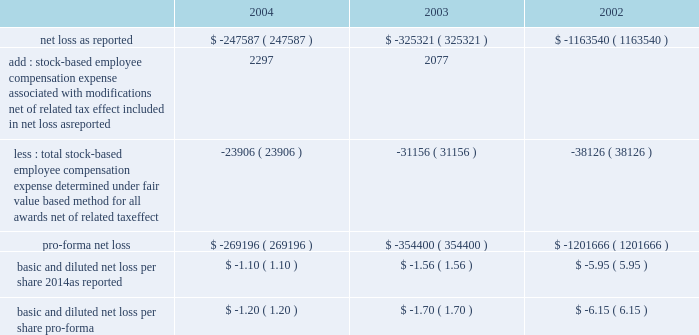American tower corporation and subsidiaries notes to consolidated financial statements 2014 ( continued ) stock-based compensation 2014the company complies with the provisions of sfas no .
148 , 201caccounting for stock-based compensation 2014transition and disclosure 2014an amendment of sfas no .
123 , 201d which provides optional transition guidance for those companies electing to voluntarily adopt the accounting provisions of sfas no .
123 .
The company continues to use accounting principles board opinion no .
25 ( apb no .
25 ) , 201caccounting for stock issued to employees , 201d to account for equity grants and awards to employees , officers and directors and has adopted the disclosure-only provisions of sfas no .
148 .
In accordance with apb no .
25 , the company recognizes compensation expense based on the excess , if any , of the quoted stock price at the grant date of the award or other measurement date over the amount an employee must pay to acquire the stock .
The company 2019s stock option plans are more fully described in note 13 .
In december 2004 , the fasb issued sfas no .
123r , 201cshare-based payment 201d ( sfas no .
123r ) , described below .
The table illustrates the effect on net loss and net loss per share if the company had applied the fair value recognition provisions of sfas no .
123 ( as amended ) to stock-based compensation .
The estimated fair value of each option is calculated using the black-scholes option-pricing model ( in thousands , except per share amounts ) : .
During the year ended december 31 , 2004 and 2003 , the company modified certain option awards to accelerate vesting and recorded charges of $ 3.0 million and $ 2.3 million , respectively , and corresponding increases to additional paid in capital in the accompanying consolidated financial statements .
Fair value of financial instruments 2014the carrying values of the company 2019s financial instruments , with the exception of long-term obligations , including current portion , reasonably approximate the related fair values as of december 31 , 2004 and 2003 .
As of december 31 , 2004 , the carrying amount and fair value of long-term obligations , including current portion , were $ 3.3 billion and $ 3.6 billion , respectively .
As of december 31 , 2003 , the carrying amount and fair value of long-term obligations , including current portion , were $ 3.4 billion and $ 3.6 billion , respectively .
Fair values are based primarily on quoted market prices for those or similar instruments .
Retirement plan 2014the company has a 401 ( k ) plan covering substantially all employees who meet certain age and employment requirements .
Under the plan , the company matching contribution for periods prior to june 30 , 2004 was 35% ( 35 % ) up to a maximum 5% ( 5 % ) of a participant 2019s contributions .
Effective july 1 , 2004 , the plan was amended to increase the company match to 50% ( 50 % ) up to a maximum 6% ( 6 % ) of a participant 2019s contributions .
The company contributed approximately $ 533000 , $ 825000 and $ 979000 to the plan for the years ended december 31 , 2004 , 2003 and 2002 , respectively .
Recent accounting pronouncements 2014in december 2004 , the fasb issued sfas no .
123r , which is a revision of sfas no .
123 , 201caccounting for stock-based compensation , 201d and supersedes apb no .
25 , accounting for .
What is the percentage change in 401 ( k ) contributed amounts from 2003 to 2004? 
Computations: ((533000 - 825000) / 825000)
Answer: -0.35394. 